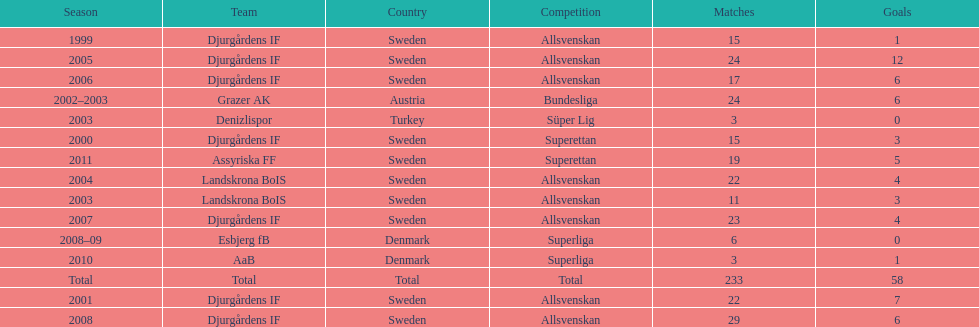What country is team djurgårdens if not from? Sweden. 